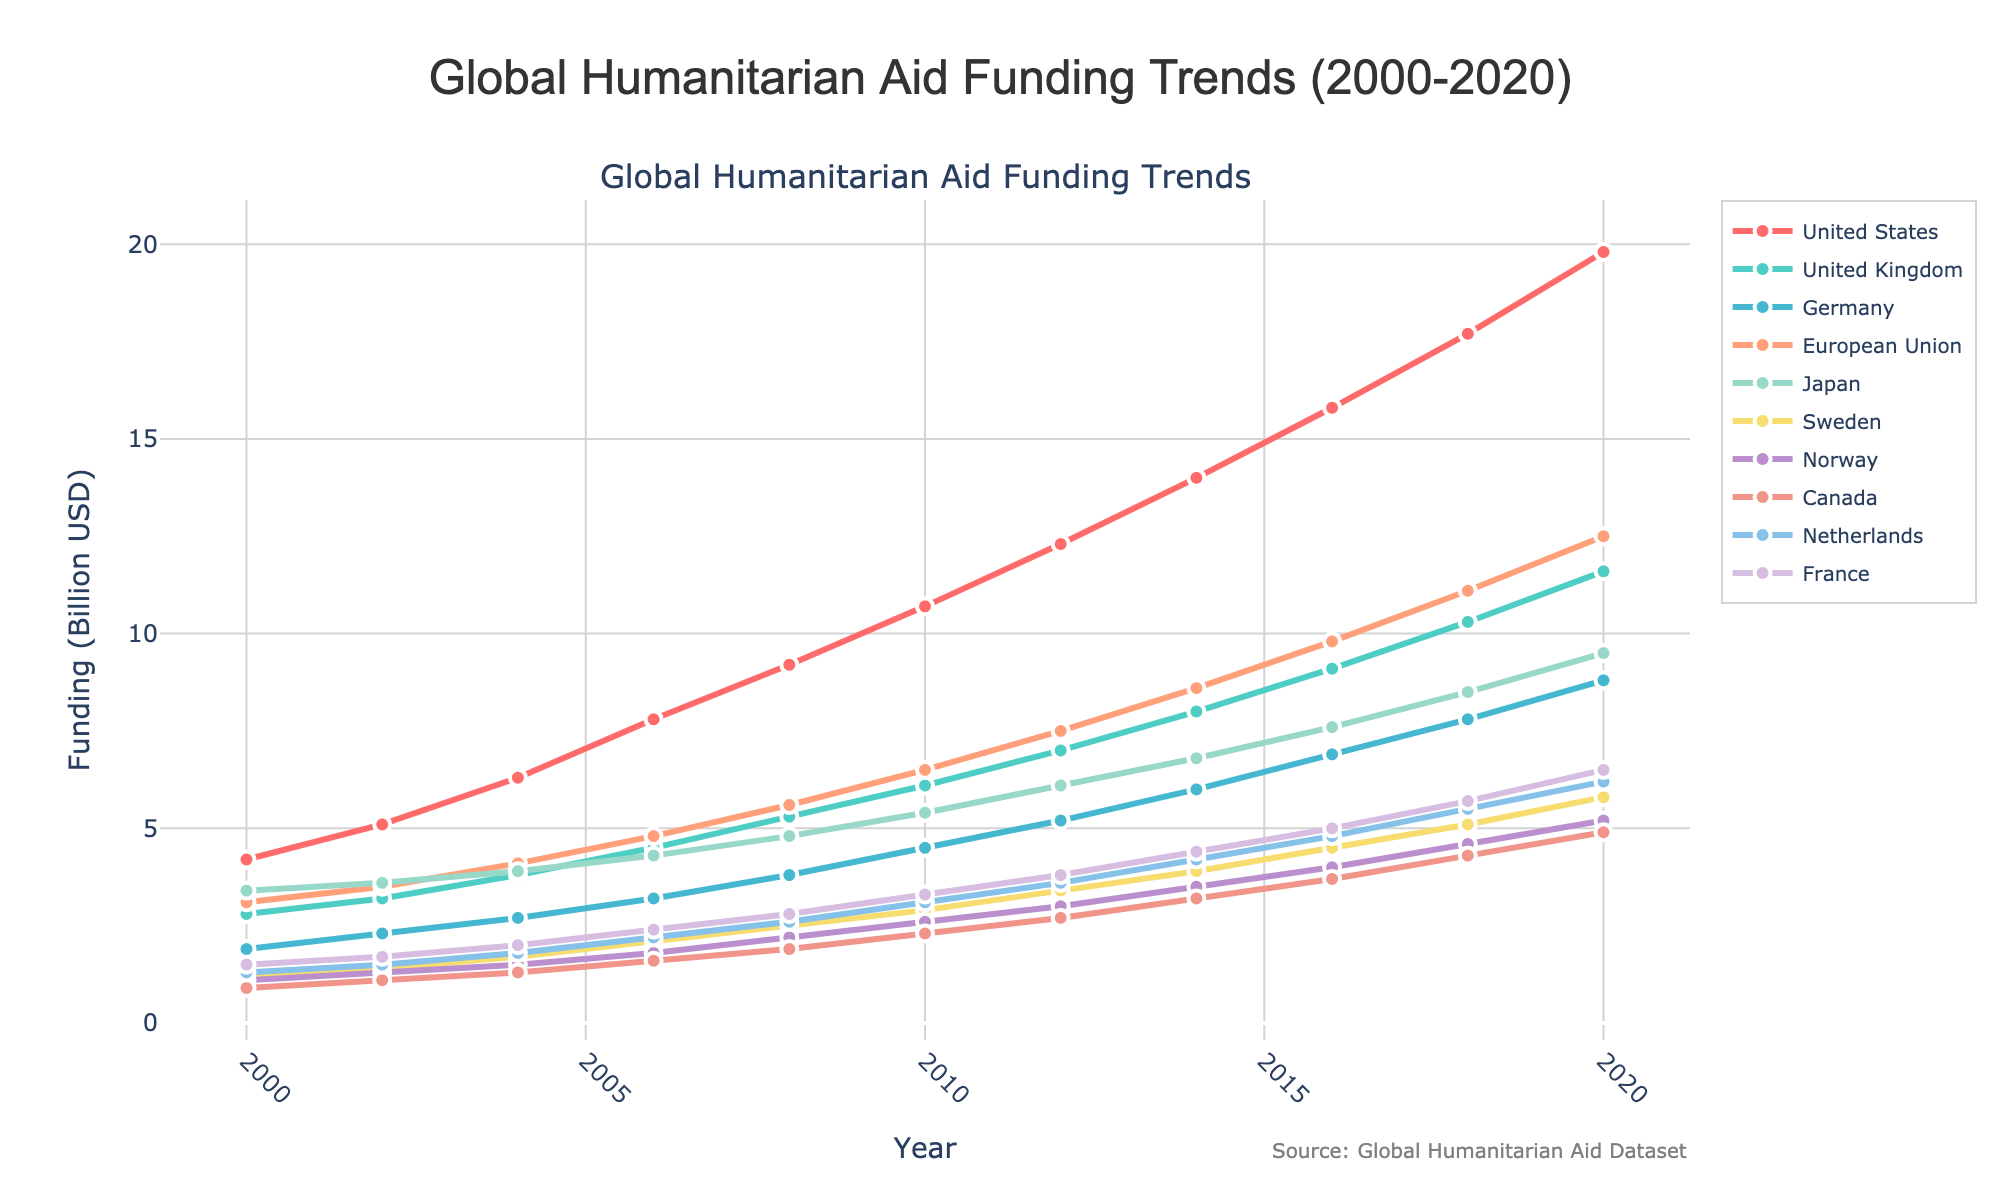What was the funding amount for the United States in 2008? Locate the line representing the United States, identified by the unique color and markers. Trace the point on this line corresponding to the year 2008 to find the value.
Answer: 9.2 billion USD Between 2002 and 2010, which country showed the largest increase in funding? Calculate the difference in funding amounts for each country between 2002 and 2010 by subtracting the 2002 value from the 2010 value. Compare these differences across all countries to identify the largest increase.
Answer: United States Which country had the lowest funding in 2004? Compare the data points for 2004 across all countries. Identify the country with the lowest value on the y-axis.
Answer: Norway Did the funding for the European Union surpass 10 billion USD at any point? Observe the line representing the European Union. Note whether it crosses the 10 billion USD mark on the y-axis from 2000 to 2020.
Answer: Yes, in 2018 Compare the funding trends of Japan and Canada. Which country had a steeper increase from 2000 to 2020? Calculate the difference in funding for Japan and Canada from 2000 to 2020. Compare the differences to determine which country had the steeper increase.
Answer: Japan In 2020, how much greater was Germany's funding compared to Canada's? Subtract the 2020 funding amount of Canada from Germany's 2020 funding amount.
Answer: 3.9 billion USD What is the average funding amount for Sweden from 2000 to 2020? Sum all funding amounts for Sweden from 2000 to 2020. Divide this sum by the number of years (11).
Answer: 3.45 billion USD Which two countries had nearly identical funding amounts in 2014? Scan the data points for 2014 across all countries. Identify any two countries with values very close to each other.
Answer: France and Netherlands Which country experienced the highest increase in funding between 2016 and 2018? Calculate the difference in funding amounts between 2016 and 2018 for each country. Identify which country had the greatest increase.
Answer: European Union Did any country’s funding decrease between any consecutive years? Examine each country’s line to see if there are any downward slopes between any consecutive years. Identify the countries and years if any.
Answer: No 